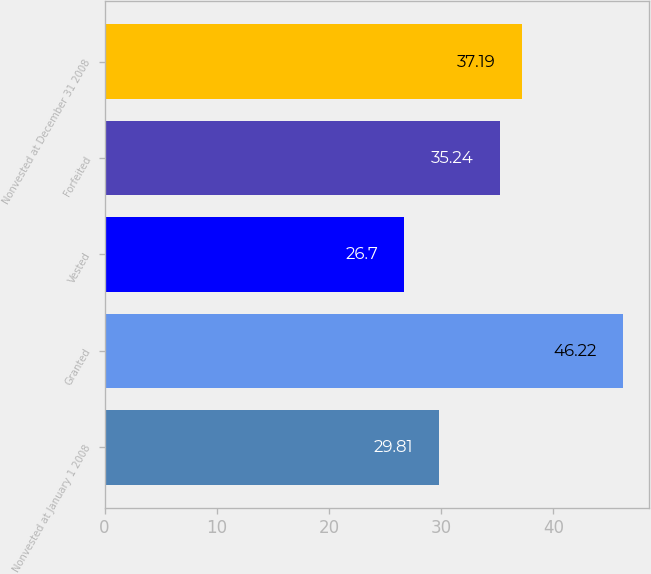Convert chart. <chart><loc_0><loc_0><loc_500><loc_500><bar_chart><fcel>Nonvested at January 1 2008<fcel>Granted<fcel>Vested<fcel>Forfeited<fcel>Nonvested at December 31 2008<nl><fcel>29.81<fcel>46.22<fcel>26.7<fcel>35.24<fcel>37.19<nl></chart> 